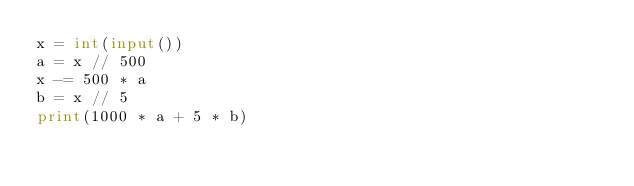Convert code to text. <code><loc_0><loc_0><loc_500><loc_500><_Python_>x = int(input())
a = x // 500
x -= 500 * a
b = x // 5
print(1000 * a + 5 * b)
</code> 